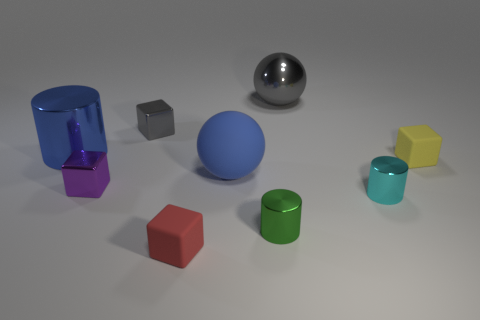What shape is the purple metallic thing that is the same size as the cyan cylinder? cube 